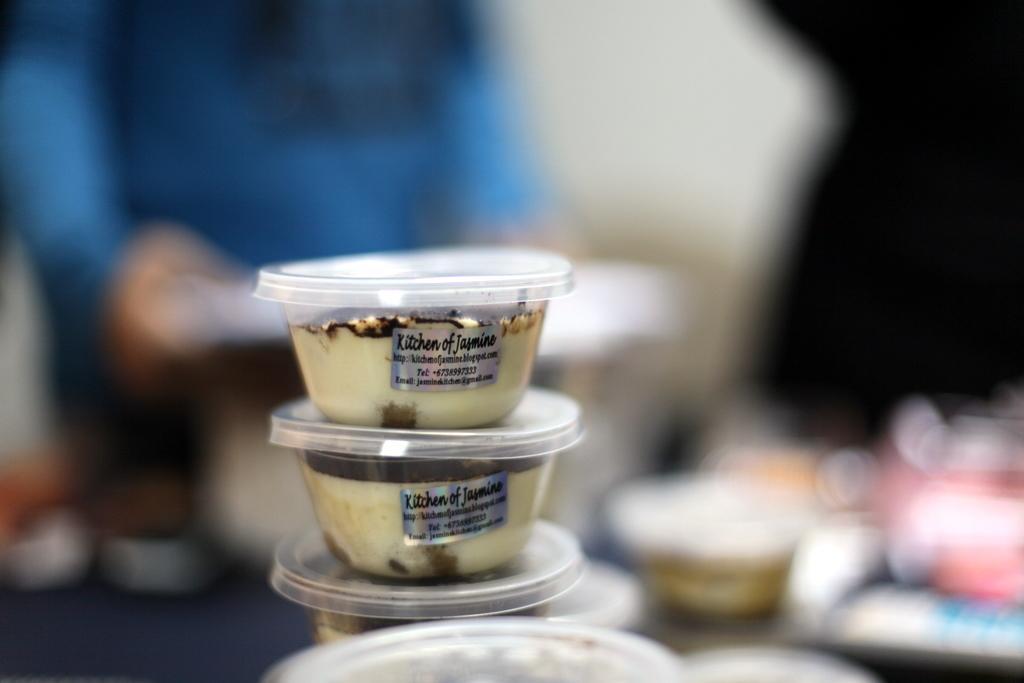Please provide a concise description of this image. In the center of the image there are ice cream cups arranged one above the other. 